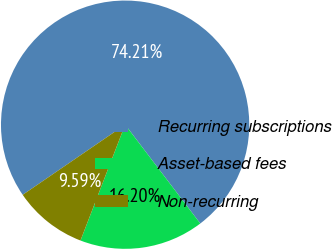<chart> <loc_0><loc_0><loc_500><loc_500><pie_chart><fcel>Recurring subscriptions<fcel>Asset-based fees<fcel>Non-recurring<nl><fcel>74.21%<fcel>16.2%<fcel>9.59%<nl></chart> 